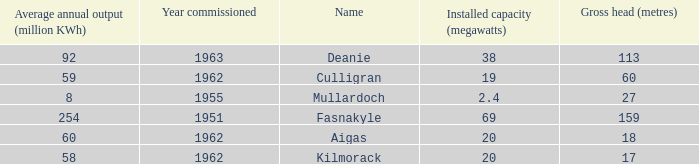What is the Year commissioned of the power station with a Gross head of 60 metres and Average annual output of less than 59 million KWh? None. 